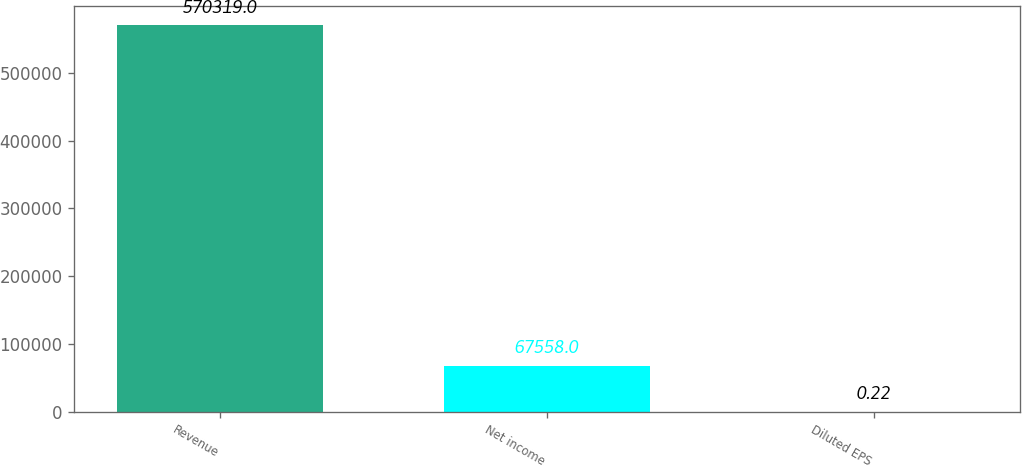Convert chart to OTSL. <chart><loc_0><loc_0><loc_500><loc_500><bar_chart><fcel>Revenue<fcel>Net income<fcel>Diluted EPS<nl><fcel>570319<fcel>67558<fcel>0.22<nl></chart> 